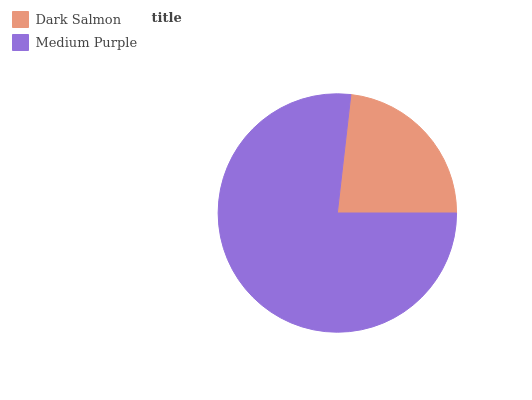Is Dark Salmon the minimum?
Answer yes or no. Yes. Is Medium Purple the maximum?
Answer yes or no. Yes. Is Medium Purple the minimum?
Answer yes or no. No. Is Medium Purple greater than Dark Salmon?
Answer yes or no. Yes. Is Dark Salmon less than Medium Purple?
Answer yes or no. Yes. Is Dark Salmon greater than Medium Purple?
Answer yes or no. No. Is Medium Purple less than Dark Salmon?
Answer yes or no. No. Is Medium Purple the high median?
Answer yes or no. Yes. Is Dark Salmon the low median?
Answer yes or no. Yes. Is Dark Salmon the high median?
Answer yes or no. No. Is Medium Purple the low median?
Answer yes or no. No. 